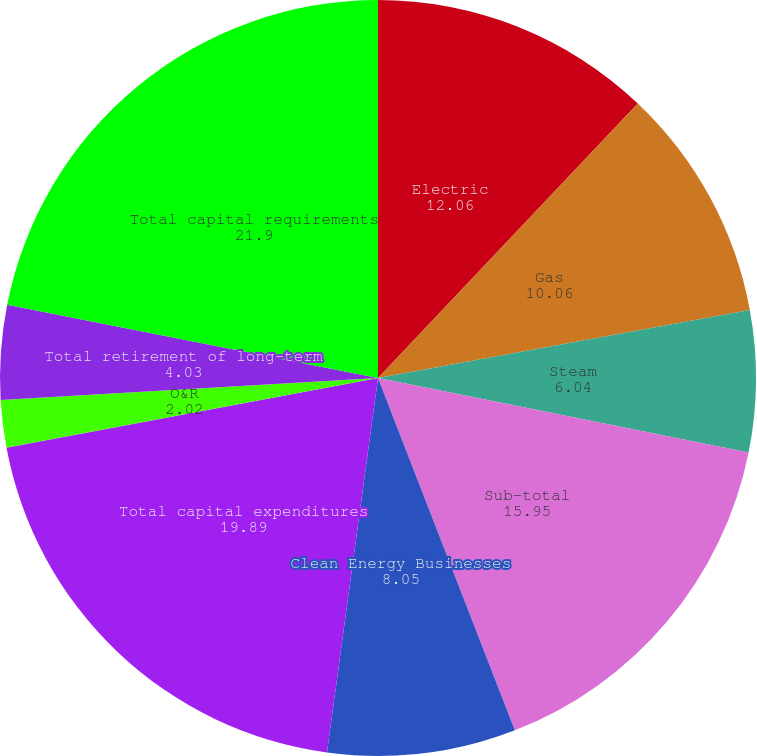Convert chart to OTSL. <chart><loc_0><loc_0><loc_500><loc_500><pie_chart><fcel>Electric<fcel>Gas<fcel>Steam<fcel>Sub-total<fcel>Clean Energy Businesses<fcel>Total capital expenditures<fcel>Con Edison - parent company<fcel>O&R<fcel>Total retirement of long-term<fcel>Total capital requirements<nl><fcel>12.06%<fcel>10.06%<fcel>6.04%<fcel>15.95%<fcel>8.05%<fcel>19.89%<fcel>0.01%<fcel>2.02%<fcel>4.03%<fcel>21.9%<nl></chart> 